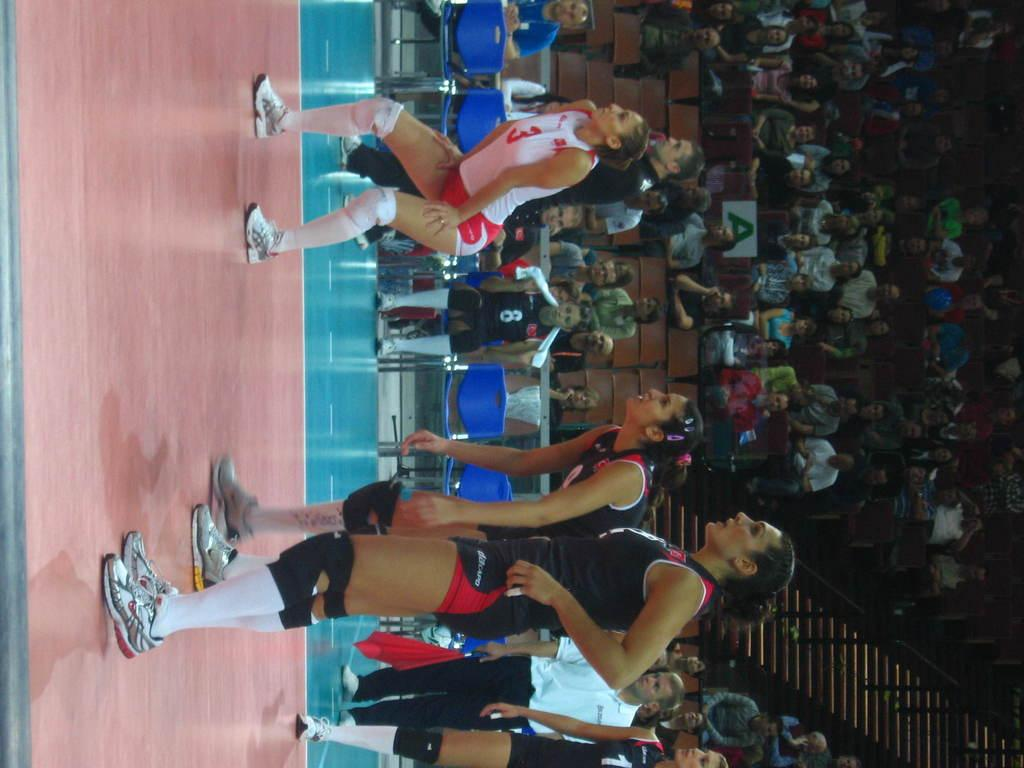What is the main subject of the image? The main subject of the image is a group of girls standing in the middle. Where are the other people in the image located? There is a group of people sitting on chairs on the right side of the image. What architectural feature can be seen in the image? There is a staircase in the bottom right-hand side of the image. What type of frame surrounds the image? The image does not have a frame; it is a photograph or digital image without a physical border. 